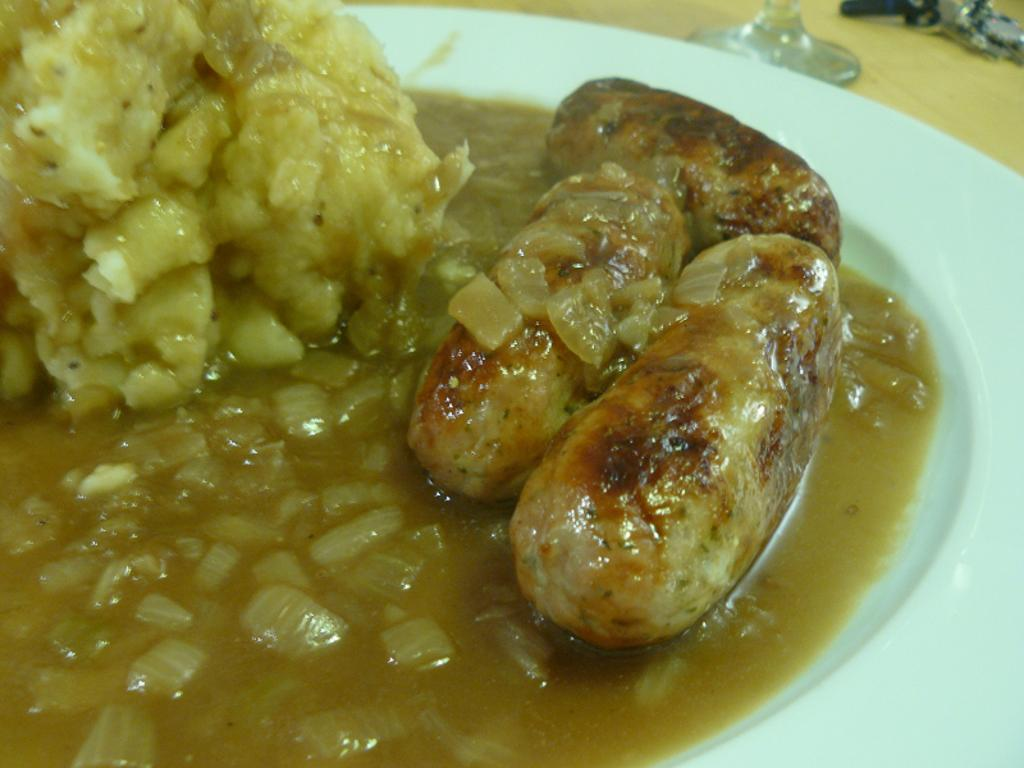What is present on the plate in the image? There is food in a plate in the image. What type of society is depicted in the image? There is no society depicted in the image; it only shows a plate of food. What hobbies are being pursued by the people in the image? There are no people present in the image, so it is impossible to determine their hobbies. 